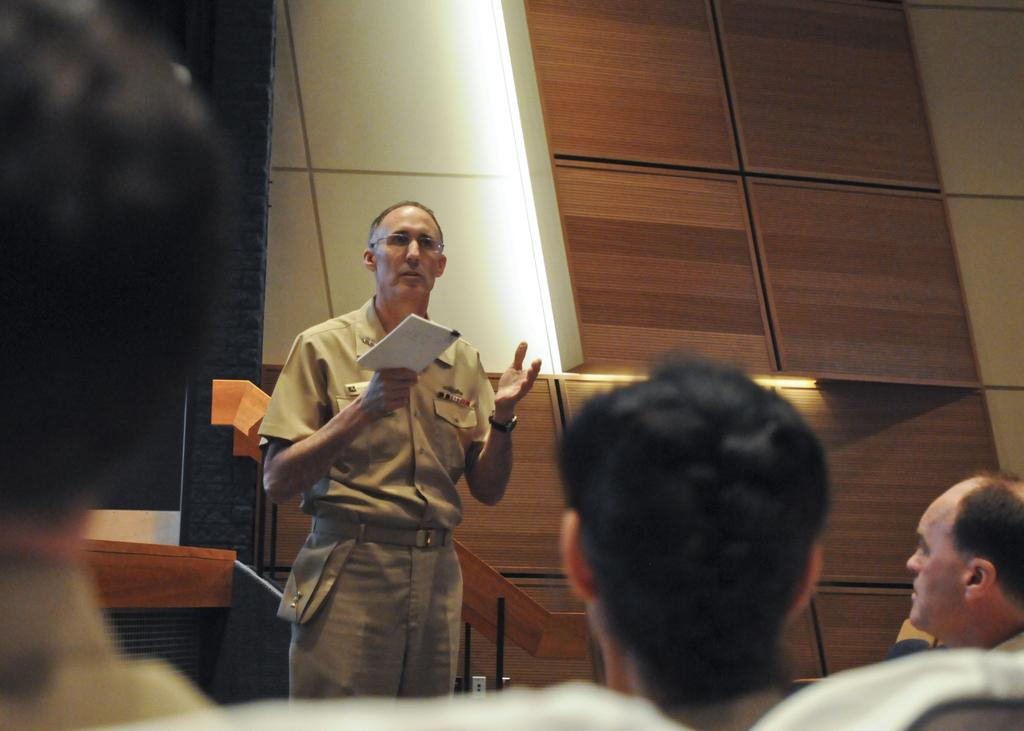How many people are in the image? There are four persons in the image. What is the man in the front holding? The man in the front is holding a book. What can be seen in the background of the image? There is a wall in the background of the image. What type of material is visible in the image? Wooden planks are visible in the image. What type of spoon is the man using to read the book in the image? There is no spoon present in the image, and the man is not using any spoon to read the book. 